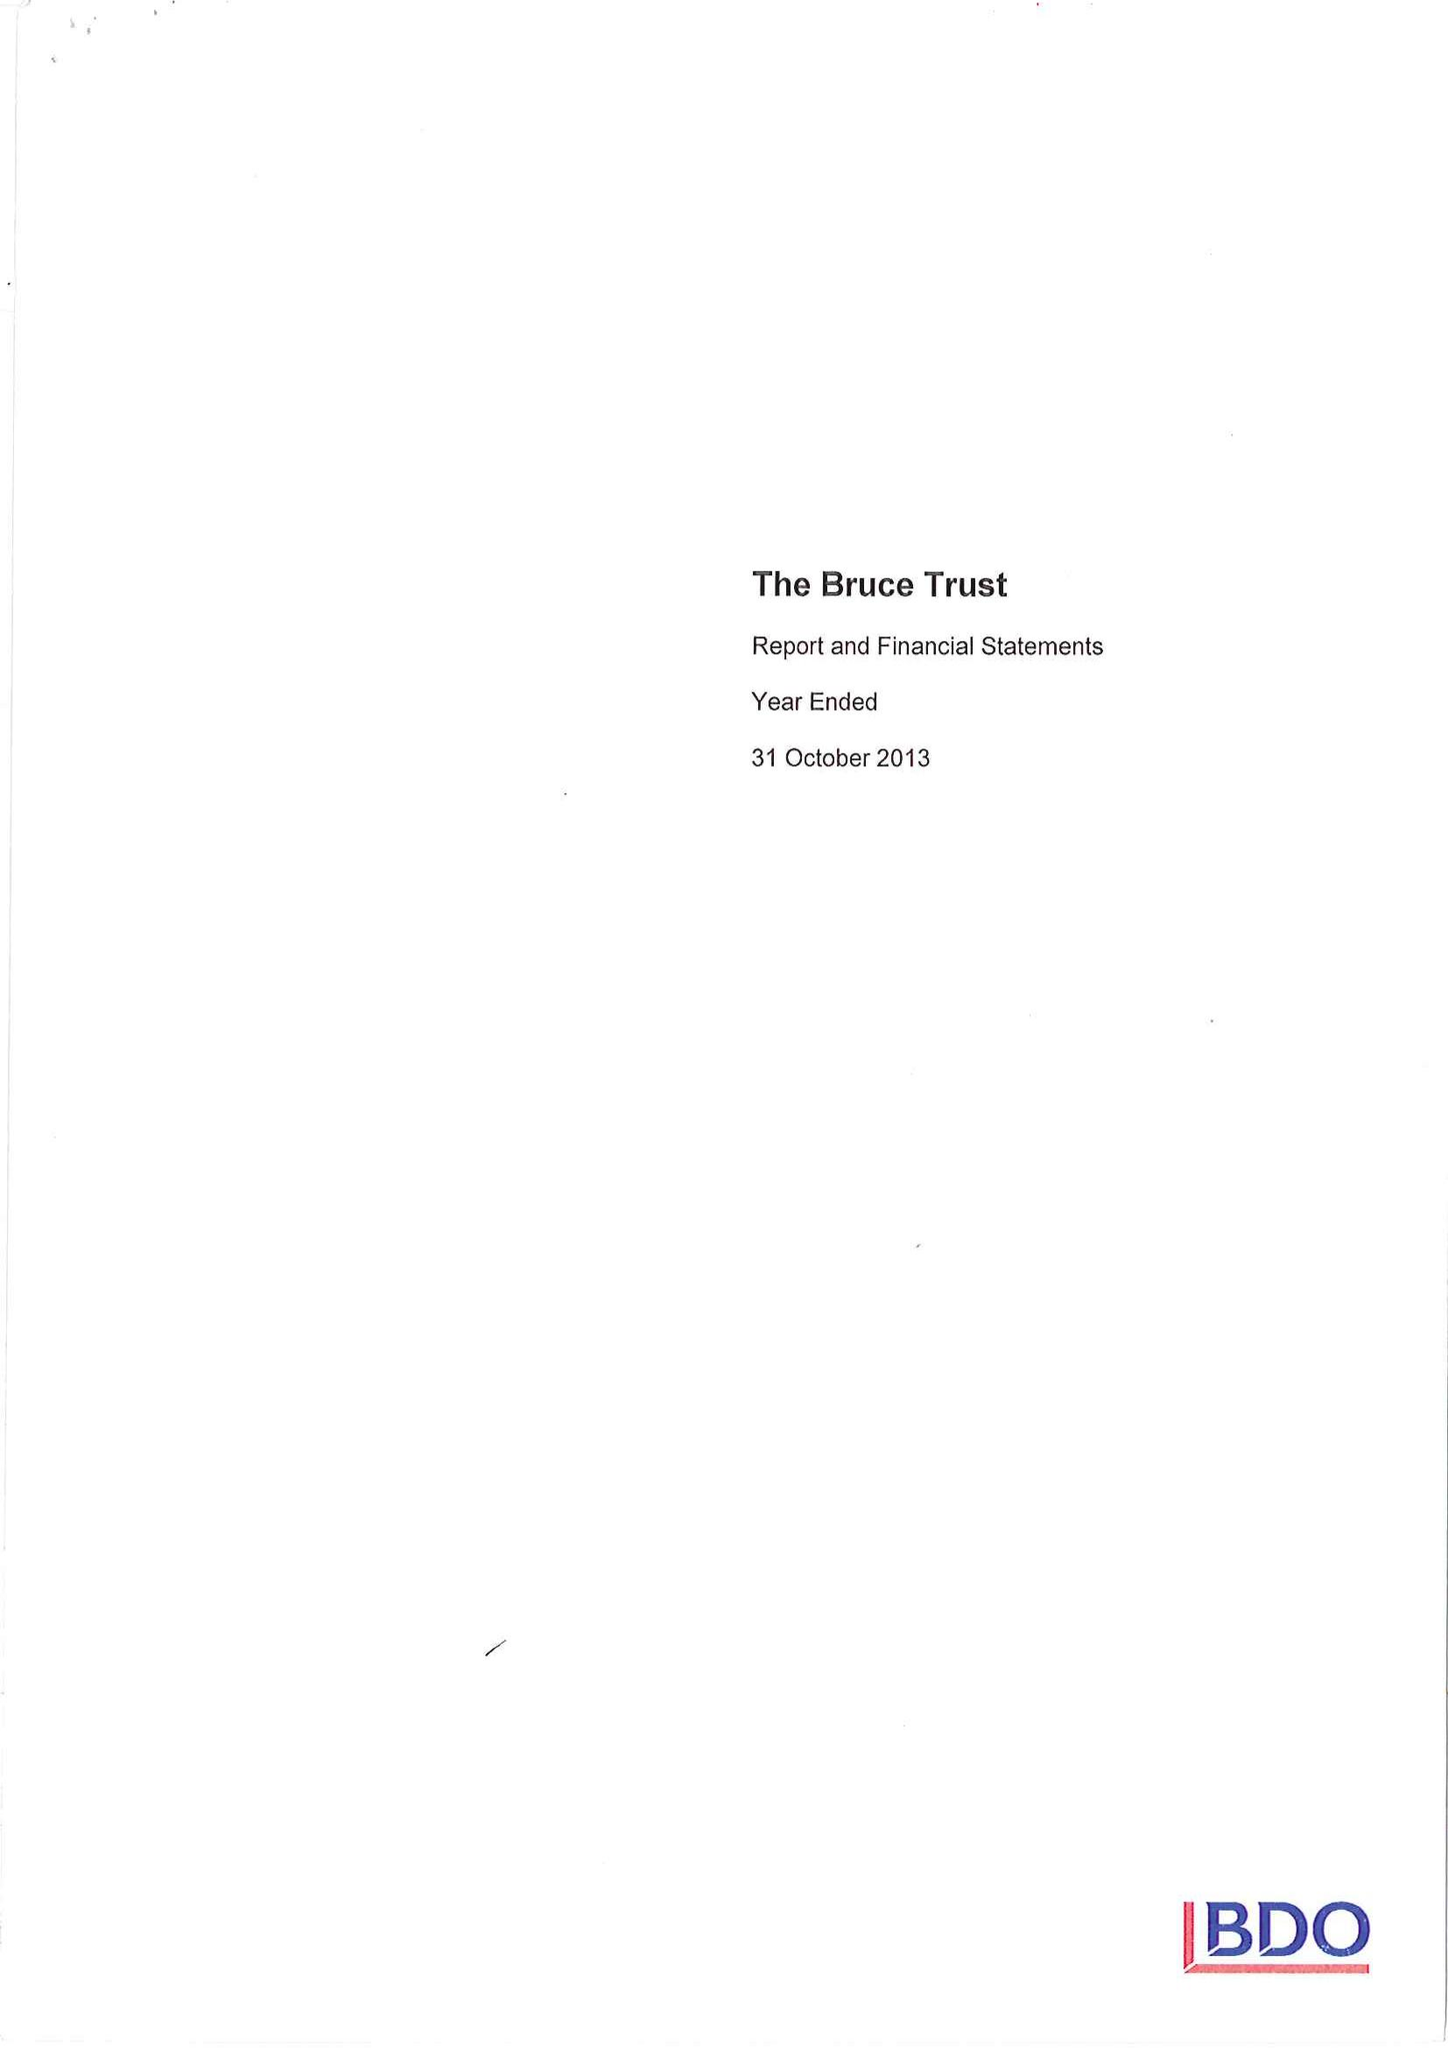What is the value for the address__street_line?
Answer the question using a single word or phrase. PO BOX 21 